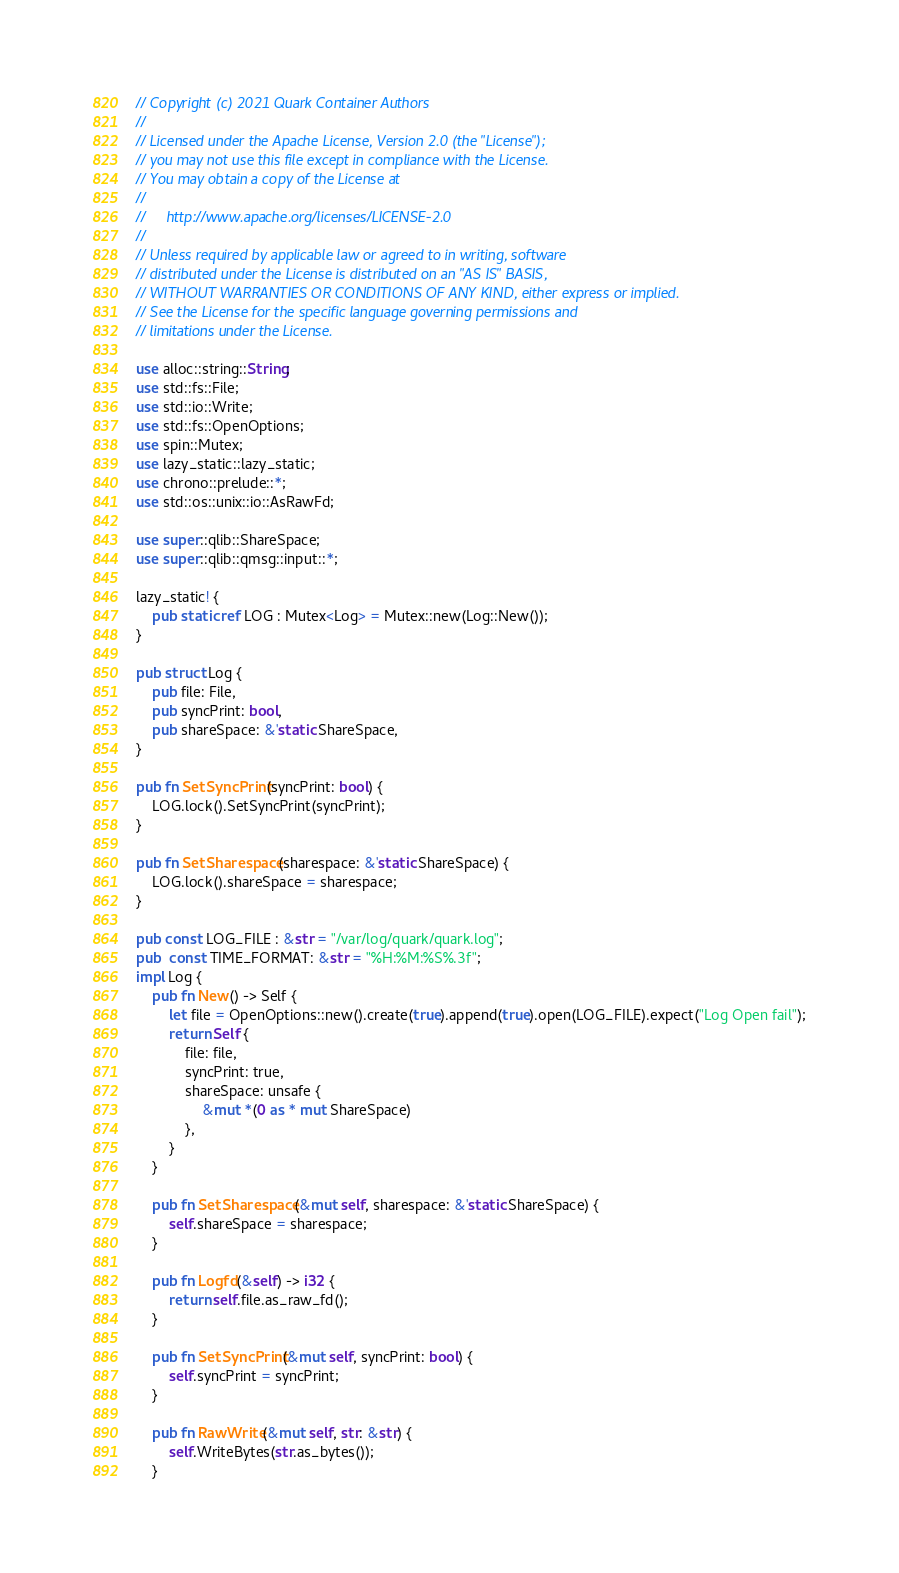<code> <loc_0><loc_0><loc_500><loc_500><_Rust_>// Copyright (c) 2021 Quark Container Authors
//
// Licensed under the Apache License, Version 2.0 (the "License");
// you may not use this file except in compliance with the License.
// You may obtain a copy of the License at
//
//     http://www.apache.org/licenses/LICENSE-2.0
//
// Unless required by applicable law or agreed to in writing, software
// distributed under the License is distributed on an "AS IS" BASIS,
// WITHOUT WARRANTIES OR CONDITIONS OF ANY KIND, either express or implied.
// See the License for the specific language governing permissions and
// limitations under the License.

use alloc::string::String;
use std::fs::File;
use std::io::Write;
use std::fs::OpenOptions;
use spin::Mutex;
use lazy_static::lazy_static;
use chrono::prelude::*;
use std::os::unix::io::AsRawFd;

use super::qlib::ShareSpace;
use super::qlib::qmsg::input::*;

lazy_static! {
    pub static ref LOG : Mutex<Log> = Mutex::new(Log::New());
}

pub struct Log {
    pub file: File,
    pub syncPrint: bool,
    pub shareSpace: &'static ShareSpace,
}

pub fn SetSyncPrint(syncPrint: bool) {
    LOG.lock().SetSyncPrint(syncPrint);
}

pub fn SetSharespace(sharespace: &'static ShareSpace) {
    LOG.lock().shareSpace = sharespace;
}

pub const LOG_FILE : &str = "/var/log/quark/quark.log";
pub  const TIME_FORMAT: &str = "%H:%M:%S%.3f";
impl Log {
    pub fn New() -> Self {
        let file = OpenOptions::new().create(true).append(true).open(LOG_FILE).expect("Log Open fail");
        return Self {
            file: file,
            syncPrint: true,
            shareSpace: unsafe {
                &mut *(0 as * mut ShareSpace)
            },
        }
    }

    pub fn SetSharespace(&mut self, sharespace: &'static ShareSpace) {
        self.shareSpace = sharespace;
    }

    pub fn Logfd(&self) -> i32 {
        return self.file.as_raw_fd();
    }

    pub fn SetSyncPrint(&mut self, syncPrint: bool) {
        self.syncPrint = syncPrint;
    }

    pub fn RawWrite(&mut self, str: &str) {
        self.WriteBytes(str.as_bytes());
    }
</code> 